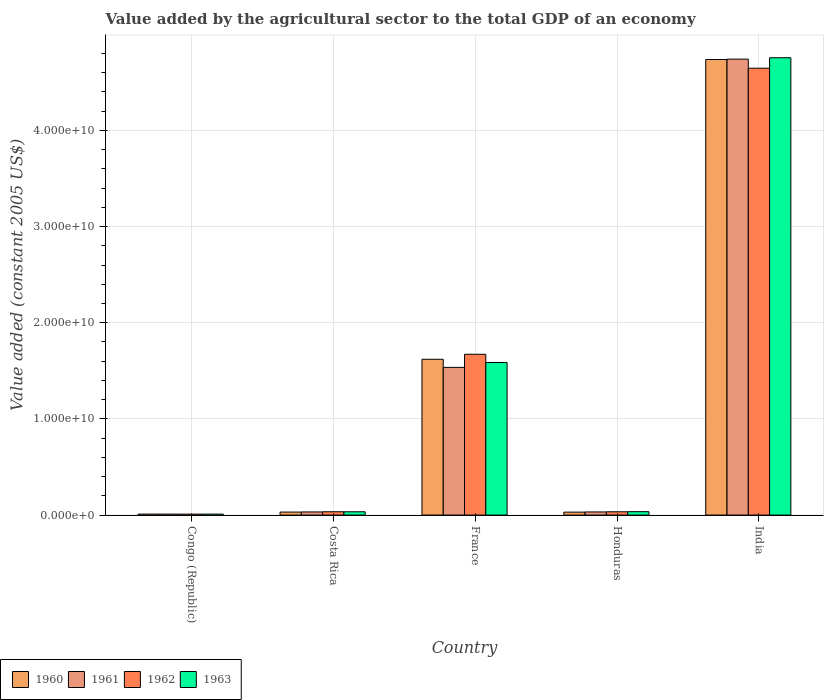How many different coloured bars are there?
Your answer should be very brief. 4. Are the number of bars per tick equal to the number of legend labels?
Keep it short and to the point. Yes. Are the number of bars on each tick of the X-axis equal?
Provide a short and direct response. Yes. How many bars are there on the 2nd tick from the left?
Offer a very short reply. 4. How many bars are there on the 2nd tick from the right?
Make the answer very short. 4. What is the label of the 4th group of bars from the left?
Your answer should be very brief. Honduras. What is the value added by the agricultural sector in 1960 in France?
Provide a succinct answer. 1.62e+1. Across all countries, what is the maximum value added by the agricultural sector in 1961?
Make the answer very short. 4.74e+1. Across all countries, what is the minimum value added by the agricultural sector in 1961?
Your answer should be compact. 9.74e+07. In which country was the value added by the agricultural sector in 1960 maximum?
Provide a short and direct response. India. In which country was the value added by the agricultural sector in 1963 minimum?
Provide a short and direct response. Congo (Republic). What is the total value added by the agricultural sector in 1961 in the graph?
Provide a short and direct response. 6.35e+1. What is the difference between the value added by the agricultural sector in 1961 in Costa Rica and that in India?
Give a very brief answer. -4.71e+1. What is the difference between the value added by the agricultural sector in 1963 in Costa Rica and the value added by the agricultural sector in 1962 in India?
Provide a short and direct response. -4.61e+1. What is the average value added by the agricultural sector in 1962 per country?
Your answer should be very brief. 1.28e+1. What is the difference between the value added by the agricultural sector of/in 1960 and value added by the agricultural sector of/in 1962 in India?
Ensure brevity in your answer.  9.03e+08. What is the ratio of the value added by the agricultural sector in 1961 in Congo (Republic) to that in India?
Make the answer very short. 0. Is the value added by the agricultural sector in 1960 in Congo (Republic) less than that in Honduras?
Ensure brevity in your answer.  Yes. Is the difference between the value added by the agricultural sector in 1960 in Costa Rica and France greater than the difference between the value added by the agricultural sector in 1962 in Costa Rica and France?
Provide a succinct answer. Yes. What is the difference between the highest and the second highest value added by the agricultural sector in 1960?
Ensure brevity in your answer.  3.12e+1. What is the difference between the highest and the lowest value added by the agricultural sector in 1962?
Offer a very short reply. 4.64e+1. Is the sum of the value added by the agricultural sector in 1960 in Costa Rica and India greater than the maximum value added by the agricultural sector in 1962 across all countries?
Your answer should be very brief. Yes. What does the 1st bar from the left in Costa Rica represents?
Offer a terse response. 1960. What does the 4th bar from the right in Congo (Republic) represents?
Make the answer very short. 1960. Is it the case that in every country, the sum of the value added by the agricultural sector in 1963 and value added by the agricultural sector in 1960 is greater than the value added by the agricultural sector in 1962?
Your answer should be very brief. Yes. How many bars are there?
Your answer should be compact. 20. Are all the bars in the graph horizontal?
Provide a succinct answer. No. How many countries are there in the graph?
Your answer should be very brief. 5. Does the graph contain any zero values?
Ensure brevity in your answer.  No. Does the graph contain grids?
Ensure brevity in your answer.  Yes. Where does the legend appear in the graph?
Offer a terse response. Bottom left. How many legend labels are there?
Keep it short and to the point. 4. What is the title of the graph?
Your answer should be very brief. Value added by the agricultural sector to the total GDP of an economy. Does "1967" appear as one of the legend labels in the graph?
Your answer should be compact. No. What is the label or title of the Y-axis?
Offer a very short reply. Value added (constant 2005 US$). What is the Value added (constant 2005 US$) in 1960 in Congo (Republic)?
Make the answer very short. 1.01e+08. What is the Value added (constant 2005 US$) of 1961 in Congo (Republic)?
Ensure brevity in your answer.  9.74e+07. What is the Value added (constant 2005 US$) in 1962 in Congo (Republic)?
Make the answer very short. 9.79e+07. What is the Value added (constant 2005 US$) in 1963 in Congo (Republic)?
Give a very brief answer. 9.86e+07. What is the Value added (constant 2005 US$) of 1960 in Costa Rica?
Give a very brief answer. 3.13e+08. What is the Value added (constant 2005 US$) in 1961 in Costa Rica?
Your response must be concise. 3.24e+08. What is the Value added (constant 2005 US$) in 1962 in Costa Rica?
Your answer should be very brief. 3.44e+08. What is the Value added (constant 2005 US$) in 1963 in Costa Rica?
Your answer should be very brief. 3.43e+08. What is the Value added (constant 2005 US$) of 1960 in France?
Your response must be concise. 1.62e+1. What is the Value added (constant 2005 US$) in 1961 in France?
Offer a terse response. 1.54e+1. What is the Value added (constant 2005 US$) of 1962 in France?
Provide a short and direct response. 1.67e+1. What is the Value added (constant 2005 US$) of 1963 in France?
Your response must be concise. 1.59e+1. What is the Value added (constant 2005 US$) in 1960 in Honduras?
Offer a very short reply. 3.05e+08. What is the Value added (constant 2005 US$) of 1961 in Honduras?
Keep it short and to the point. 3.25e+08. What is the Value added (constant 2005 US$) in 1962 in Honduras?
Your answer should be compact. 3.41e+08. What is the Value added (constant 2005 US$) of 1963 in Honduras?
Your answer should be very brief. 3.53e+08. What is the Value added (constant 2005 US$) of 1960 in India?
Offer a very short reply. 4.74e+1. What is the Value added (constant 2005 US$) of 1961 in India?
Keep it short and to the point. 4.74e+1. What is the Value added (constant 2005 US$) of 1962 in India?
Offer a terse response. 4.65e+1. What is the Value added (constant 2005 US$) of 1963 in India?
Provide a short and direct response. 4.76e+1. Across all countries, what is the maximum Value added (constant 2005 US$) of 1960?
Your answer should be compact. 4.74e+1. Across all countries, what is the maximum Value added (constant 2005 US$) in 1961?
Ensure brevity in your answer.  4.74e+1. Across all countries, what is the maximum Value added (constant 2005 US$) in 1962?
Ensure brevity in your answer.  4.65e+1. Across all countries, what is the maximum Value added (constant 2005 US$) of 1963?
Offer a terse response. 4.76e+1. Across all countries, what is the minimum Value added (constant 2005 US$) of 1960?
Offer a very short reply. 1.01e+08. Across all countries, what is the minimum Value added (constant 2005 US$) of 1961?
Your answer should be compact. 9.74e+07. Across all countries, what is the minimum Value added (constant 2005 US$) in 1962?
Offer a terse response. 9.79e+07. Across all countries, what is the minimum Value added (constant 2005 US$) in 1963?
Provide a short and direct response. 9.86e+07. What is the total Value added (constant 2005 US$) in 1960 in the graph?
Provide a short and direct response. 6.43e+1. What is the total Value added (constant 2005 US$) of 1961 in the graph?
Offer a terse response. 6.35e+1. What is the total Value added (constant 2005 US$) in 1962 in the graph?
Give a very brief answer. 6.40e+1. What is the total Value added (constant 2005 US$) of 1963 in the graph?
Give a very brief answer. 6.42e+1. What is the difference between the Value added (constant 2005 US$) in 1960 in Congo (Republic) and that in Costa Rica?
Keep it short and to the point. -2.12e+08. What is the difference between the Value added (constant 2005 US$) in 1961 in Congo (Republic) and that in Costa Rica?
Your answer should be compact. -2.27e+08. What is the difference between the Value added (constant 2005 US$) in 1962 in Congo (Republic) and that in Costa Rica?
Provide a short and direct response. -2.46e+08. What is the difference between the Value added (constant 2005 US$) of 1963 in Congo (Republic) and that in Costa Rica?
Provide a short and direct response. -2.45e+08. What is the difference between the Value added (constant 2005 US$) in 1960 in Congo (Republic) and that in France?
Ensure brevity in your answer.  -1.61e+1. What is the difference between the Value added (constant 2005 US$) in 1961 in Congo (Republic) and that in France?
Offer a terse response. -1.53e+1. What is the difference between the Value added (constant 2005 US$) in 1962 in Congo (Republic) and that in France?
Provide a short and direct response. -1.66e+1. What is the difference between the Value added (constant 2005 US$) of 1963 in Congo (Republic) and that in France?
Offer a very short reply. -1.58e+1. What is the difference between the Value added (constant 2005 US$) of 1960 in Congo (Republic) and that in Honduras?
Your answer should be compact. -2.04e+08. What is the difference between the Value added (constant 2005 US$) in 1961 in Congo (Republic) and that in Honduras?
Provide a short and direct response. -2.28e+08. What is the difference between the Value added (constant 2005 US$) in 1962 in Congo (Republic) and that in Honduras?
Your response must be concise. -2.43e+08. What is the difference between the Value added (constant 2005 US$) in 1963 in Congo (Republic) and that in Honduras?
Provide a short and direct response. -2.55e+08. What is the difference between the Value added (constant 2005 US$) in 1960 in Congo (Republic) and that in India?
Make the answer very short. -4.73e+1. What is the difference between the Value added (constant 2005 US$) in 1961 in Congo (Republic) and that in India?
Your response must be concise. -4.73e+1. What is the difference between the Value added (constant 2005 US$) of 1962 in Congo (Republic) and that in India?
Your answer should be very brief. -4.64e+1. What is the difference between the Value added (constant 2005 US$) in 1963 in Congo (Republic) and that in India?
Offer a very short reply. -4.75e+1. What is the difference between the Value added (constant 2005 US$) of 1960 in Costa Rica and that in France?
Make the answer very short. -1.59e+1. What is the difference between the Value added (constant 2005 US$) of 1961 in Costa Rica and that in France?
Make the answer very short. -1.50e+1. What is the difference between the Value added (constant 2005 US$) of 1962 in Costa Rica and that in France?
Your response must be concise. -1.64e+1. What is the difference between the Value added (constant 2005 US$) in 1963 in Costa Rica and that in France?
Your answer should be compact. -1.55e+1. What is the difference between the Value added (constant 2005 US$) of 1960 in Costa Rica and that in Honduras?
Keep it short and to the point. 7.61e+06. What is the difference between the Value added (constant 2005 US$) in 1961 in Costa Rica and that in Honduras?
Offer a very short reply. -8.14e+05. What is the difference between the Value added (constant 2005 US$) of 1962 in Costa Rica and that in Honduras?
Your answer should be compact. 3.61e+06. What is the difference between the Value added (constant 2005 US$) in 1963 in Costa Rica and that in Honduras?
Ensure brevity in your answer.  -9.78e+06. What is the difference between the Value added (constant 2005 US$) of 1960 in Costa Rica and that in India?
Provide a short and direct response. -4.71e+1. What is the difference between the Value added (constant 2005 US$) of 1961 in Costa Rica and that in India?
Your answer should be compact. -4.71e+1. What is the difference between the Value added (constant 2005 US$) in 1962 in Costa Rica and that in India?
Keep it short and to the point. -4.61e+1. What is the difference between the Value added (constant 2005 US$) of 1963 in Costa Rica and that in India?
Your answer should be compact. -4.72e+1. What is the difference between the Value added (constant 2005 US$) of 1960 in France and that in Honduras?
Offer a very short reply. 1.59e+1. What is the difference between the Value added (constant 2005 US$) of 1961 in France and that in Honduras?
Provide a succinct answer. 1.50e+1. What is the difference between the Value added (constant 2005 US$) in 1962 in France and that in Honduras?
Your response must be concise. 1.64e+1. What is the difference between the Value added (constant 2005 US$) of 1963 in France and that in Honduras?
Make the answer very short. 1.55e+1. What is the difference between the Value added (constant 2005 US$) of 1960 in France and that in India?
Your answer should be very brief. -3.12e+1. What is the difference between the Value added (constant 2005 US$) in 1961 in France and that in India?
Your answer should be compact. -3.21e+1. What is the difference between the Value added (constant 2005 US$) of 1962 in France and that in India?
Your answer should be compact. -2.97e+1. What is the difference between the Value added (constant 2005 US$) of 1963 in France and that in India?
Make the answer very short. -3.17e+1. What is the difference between the Value added (constant 2005 US$) of 1960 in Honduras and that in India?
Make the answer very short. -4.71e+1. What is the difference between the Value added (constant 2005 US$) in 1961 in Honduras and that in India?
Provide a succinct answer. -4.71e+1. What is the difference between the Value added (constant 2005 US$) of 1962 in Honduras and that in India?
Ensure brevity in your answer.  -4.61e+1. What is the difference between the Value added (constant 2005 US$) in 1963 in Honduras and that in India?
Your answer should be compact. -4.72e+1. What is the difference between the Value added (constant 2005 US$) of 1960 in Congo (Republic) and the Value added (constant 2005 US$) of 1961 in Costa Rica?
Offer a very short reply. -2.24e+08. What is the difference between the Value added (constant 2005 US$) of 1960 in Congo (Republic) and the Value added (constant 2005 US$) of 1962 in Costa Rica?
Ensure brevity in your answer.  -2.43e+08. What is the difference between the Value added (constant 2005 US$) of 1960 in Congo (Republic) and the Value added (constant 2005 US$) of 1963 in Costa Rica?
Keep it short and to the point. -2.42e+08. What is the difference between the Value added (constant 2005 US$) of 1961 in Congo (Republic) and the Value added (constant 2005 US$) of 1962 in Costa Rica?
Provide a succinct answer. -2.47e+08. What is the difference between the Value added (constant 2005 US$) of 1961 in Congo (Republic) and the Value added (constant 2005 US$) of 1963 in Costa Rica?
Ensure brevity in your answer.  -2.46e+08. What is the difference between the Value added (constant 2005 US$) of 1962 in Congo (Republic) and the Value added (constant 2005 US$) of 1963 in Costa Rica?
Your response must be concise. -2.45e+08. What is the difference between the Value added (constant 2005 US$) in 1960 in Congo (Republic) and the Value added (constant 2005 US$) in 1961 in France?
Provide a short and direct response. -1.53e+1. What is the difference between the Value added (constant 2005 US$) in 1960 in Congo (Republic) and the Value added (constant 2005 US$) in 1962 in France?
Offer a very short reply. -1.66e+1. What is the difference between the Value added (constant 2005 US$) of 1960 in Congo (Republic) and the Value added (constant 2005 US$) of 1963 in France?
Ensure brevity in your answer.  -1.58e+1. What is the difference between the Value added (constant 2005 US$) in 1961 in Congo (Republic) and the Value added (constant 2005 US$) in 1962 in France?
Make the answer very short. -1.66e+1. What is the difference between the Value added (constant 2005 US$) in 1961 in Congo (Republic) and the Value added (constant 2005 US$) in 1963 in France?
Your answer should be compact. -1.58e+1. What is the difference between the Value added (constant 2005 US$) of 1962 in Congo (Republic) and the Value added (constant 2005 US$) of 1963 in France?
Provide a succinct answer. -1.58e+1. What is the difference between the Value added (constant 2005 US$) in 1960 in Congo (Republic) and the Value added (constant 2005 US$) in 1961 in Honduras?
Your response must be concise. -2.24e+08. What is the difference between the Value added (constant 2005 US$) in 1960 in Congo (Republic) and the Value added (constant 2005 US$) in 1962 in Honduras?
Offer a very short reply. -2.40e+08. What is the difference between the Value added (constant 2005 US$) of 1960 in Congo (Republic) and the Value added (constant 2005 US$) of 1963 in Honduras?
Provide a short and direct response. -2.52e+08. What is the difference between the Value added (constant 2005 US$) of 1961 in Congo (Republic) and the Value added (constant 2005 US$) of 1962 in Honduras?
Offer a very short reply. -2.43e+08. What is the difference between the Value added (constant 2005 US$) in 1961 in Congo (Republic) and the Value added (constant 2005 US$) in 1963 in Honduras?
Your answer should be compact. -2.56e+08. What is the difference between the Value added (constant 2005 US$) of 1962 in Congo (Republic) and the Value added (constant 2005 US$) of 1963 in Honduras?
Your answer should be very brief. -2.55e+08. What is the difference between the Value added (constant 2005 US$) of 1960 in Congo (Republic) and the Value added (constant 2005 US$) of 1961 in India?
Provide a short and direct response. -4.73e+1. What is the difference between the Value added (constant 2005 US$) of 1960 in Congo (Republic) and the Value added (constant 2005 US$) of 1962 in India?
Keep it short and to the point. -4.64e+1. What is the difference between the Value added (constant 2005 US$) in 1960 in Congo (Republic) and the Value added (constant 2005 US$) in 1963 in India?
Offer a terse response. -4.75e+1. What is the difference between the Value added (constant 2005 US$) in 1961 in Congo (Republic) and the Value added (constant 2005 US$) in 1962 in India?
Offer a terse response. -4.64e+1. What is the difference between the Value added (constant 2005 US$) of 1961 in Congo (Republic) and the Value added (constant 2005 US$) of 1963 in India?
Offer a very short reply. -4.75e+1. What is the difference between the Value added (constant 2005 US$) of 1962 in Congo (Republic) and the Value added (constant 2005 US$) of 1963 in India?
Keep it short and to the point. -4.75e+1. What is the difference between the Value added (constant 2005 US$) in 1960 in Costa Rica and the Value added (constant 2005 US$) in 1961 in France?
Provide a succinct answer. -1.50e+1. What is the difference between the Value added (constant 2005 US$) of 1960 in Costa Rica and the Value added (constant 2005 US$) of 1962 in France?
Make the answer very short. -1.64e+1. What is the difference between the Value added (constant 2005 US$) in 1960 in Costa Rica and the Value added (constant 2005 US$) in 1963 in France?
Offer a very short reply. -1.56e+1. What is the difference between the Value added (constant 2005 US$) in 1961 in Costa Rica and the Value added (constant 2005 US$) in 1962 in France?
Your answer should be very brief. -1.64e+1. What is the difference between the Value added (constant 2005 US$) in 1961 in Costa Rica and the Value added (constant 2005 US$) in 1963 in France?
Make the answer very short. -1.55e+1. What is the difference between the Value added (constant 2005 US$) in 1962 in Costa Rica and the Value added (constant 2005 US$) in 1963 in France?
Provide a short and direct response. -1.55e+1. What is the difference between the Value added (constant 2005 US$) of 1960 in Costa Rica and the Value added (constant 2005 US$) of 1961 in Honduras?
Offer a terse response. -1.23e+07. What is the difference between the Value added (constant 2005 US$) in 1960 in Costa Rica and the Value added (constant 2005 US$) in 1962 in Honduras?
Provide a short and direct response. -2.78e+07. What is the difference between the Value added (constant 2005 US$) of 1960 in Costa Rica and the Value added (constant 2005 US$) of 1963 in Honduras?
Offer a very short reply. -4.02e+07. What is the difference between the Value added (constant 2005 US$) of 1961 in Costa Rica and the Value added (constant 2005 US$) of 1962 in Honduras?
Offer a terse response. -1.63e+07. What is the difference between the Value added (constant 2005 US$) in 1961 in Costa Rica and the Value added (constant 2005 US$) in 1963 in Honduras?
Your answer should be very brief. -2.87e+07. What is the difference between the Value added (constant 2005 US$) of 1962 in Costa Rica and the Value added (constant 2005 US$) of 1963 in Honduras?
Give a very brief answer. -8.78e+06. What is the difference between the Value added (constant 2005 US$) of 1960 in Costa Rica and the Value added (constant 2005 US$) of 1961 in India?
Make the answer very short. -4.71e+1. What is the difference between the Value added (constant 2005 US$) of 1960 in Costa Rica and the Value added (constant 2005 US$) of 1962 in India?
Your answer should be very brief. -4.62e+1. What is the difference between the Value added (constant 2005 US$) of 1960 in Costa Rica and the Value added (constant 2005 US$) of 1963 in India?
Provide a short and direct response. -4.72e+1. What is the difference between the Value added (constant 2005 US$) of 1961 in Costa Rica and the Value added (constant 2005 US$) of 1962 in India?
Give a very brief answer. -4.61e+1. What is the difference between the Value added (constant 2005 US$) in 1961 in Costa Rica and the Value added (constant 2005 US$) in 1963 in India?
Provide a short and direct response. -4.72e+1. What is the difference between the Value added (constant 2005 US$) in 1962 in Costa Rica and the Value added (constant 2005 US$) in 1963 in India?
Offer a very short reply. -4.72e+1. What is the difference between the Value added (constant 2005 US$) in 1960 in France and the Value added (constant 2005 US$) in 1961 in Honduras?
Offer a terse response. 1.59e+1. What is the difference between the Value added (constant 2005 US$) of 1960 in France and the Value added (constant 2005 US$) of 1962 in Honduras?
Offer a very short reply. 1.59e+1. What is the difference between the Value added (constant 2005 US$) of 1960 in France and the Value added (constant 2005 US$) of 1963 in Honduras?
Your answer should be compact. 1.58e+1. What is the difference between the Value added (constant 2005 US$) in 1961 in France and the Value added (constant 2005 US$) in 1962 in Honduras?
Provide a short and direct response. 1.50e+1. What is the difference between the Value added (constant 2005 US$) of 1961 in France and the Value added (constant 2005 US$) of 1963 in Honduras?
Keep it short and to the point. 1.50e+1. What is the difference between the Value added (constant 2005 US$) in 1962 in France and the Value added (constant 2005 US$) in 1963 in Honduras?
Offer a very short reply. 1.64e+1. What is the difference between the Value added (constant 2005 US$) of 1960 in France and the Value added (constant 2005 US$) of 1961 in India?
Make the answer very short. -3.12e+1. What is the difference between the Value added (constant 2005 US$) in 1960 in France and the Value added (constant 2005 US$) in 1962 in India?
Keep it short and to the point. -3.03e+1. What is the difference between the Value added (constant 2005 US$) of 1960 in France and the Value added (constant 2005 US$) of 1963 in India?
Your answer should be very brief. -3.14e+1. What is the difference between the Value added (constant 2005 US$) in 1961 in France and the Value added (constant 2005 US$) in 1962 in India?
Your answer should be compact. -3.11e+1. What is the difference between the Value added (constant 2005 US$) in 1961 in France and the Value added (constant 2005 US$) in 1963 in India?
Your answer should be compact. -3.22e+1. What is the difference between the Value added (constant 2005 US$) in 1962 in France and the Value added (constant 2005 US$) in 1963 in India?
Your answer should be very brief. -3.08e+1. What is the difference between the Value added (constant 2005 US$) in 1960 in Honduras and the Value added (constant 2005 US$) in 1961 in India?
Give a very brief answer. -4.71e+1. What is the difference between the Value added (constant 2005 US$) of 1960 in Honduras and the Value added (constant 2005 US$) of 1962 in India?
Offer a very short reply. -4.62e+1. What is the difference between the Value added (constant 2005 US$) in 1960 in Honduras and the Value added (constant 2005 US$) in 1963 in India?
Make the answer very short. -4.72e+1. What is the difference between the Value added (constant 2005 US$) in 1961 in Honduras and the Value added (constant 2005 US$) in 1962 in India?
Offer a terse response. -4.61e+1. What is the difference between the Value added (constant 2005 US$) of 1961 in Honduras and the Value added (constant 2005 US$) of 1963 in India?
Give a very brief answer. -4.72e+1. What is the difference between the Value added (constant 2005 US$) of 1962 in Honduras and the Value added (constant 2005 US$) of 1963 in India?
Ensure brevity in your answer.  -4.72e+1. What is the average Value added (constant 2005 US$) of 1960 per country?
Offer a terse response. 1.29e+1. What is the average Value added (constant 2005 US$) in 1961 per country?
Provide a short and direct response. 1.27e+1. What is the average Value added (constant 2005 US$) of 1962 per country?
Offer a very short reply. 1.28e+1. What is the average Value added (constant 2005 US$) in 1963 per country?
Offer a terse response. 1.28e+1. What is the difference between the Value added (constant 2005 US$) in 1960 and Value added (constant 2005 US$) in 1961 in Congo (Republic)?
Your answer should be compact. 3.61e+06. What is the difference between the Value added (constant 2005 US$) in 1960 and Value added (constant 2005 US$) in 1962 in Congo (Republic)?
Provide a succinct answer. 3.02e+06. What is the difference between the Value added (constant 2005 US$) of 1960 and Value added (constant 2005 US$) of 1963 in Congo (Republic)?
Your answer should be compact. 2.34e+06. What is the difference between the Value added (constant 2005 US$) of 1961 and Value added (constant 2005 US$) of 1962 in Congo (Republic)?
Your answer should be very brief. -5.86e+05. What is the difference between the Value added (constant 2005 US$) of 1961 and Value added (constant 2005 US$) of 1963 in Congo (Republic)?
Your answer should be very brief. -1.27e+06. What is the difference between the Value added (constant 2005 US$) in 1962 and Value added (constant 2005 US$) in 1963 in Congo (Republic)?
Provide a succinct answer. -6.85e+05. What is the difference between the Value added (constant 2005 US$) of 1960 and Value added (constant 2005 US$) of 1961 in Costa Rica?
Give a very brief answer. -1.15e+07. What is the difference between the Value added (constant 2005 US$) of 1960 and Value added (constant 2005 US$) of 1962 in Costa Rica?
Your answer should be compact. -3.14e+07. What is the difference between the Value added (constant 2005 US$) in 1960 and Value added (constant 2005 US$) in 1963 in Costa Rica?
Make the answer very short. -3.04e+07. What is the difference between the Value added (constant 2005 US$) of 1961 and Value added (constant 2005 US$) of 1962 in Costa Rica?
Ensure brevity in your answer.  -1.99e+07. What is the difference between the Value added (constant 2005 US$) in 1961 and Value added (constant 2005 US$) in 1963 in Costa Rica?
Your response must be concise. -1.89e+07. What is the difference between the Value added (constant 2005 US$) in 1962 and Value added (constant 2005 US$) in 1963 in Costa Rica?
Provide a short and direct response. 1.00e+06. What is the difference between the Value added (constant 2005 US$) of 1960 and Value added (constant 2005 US$) of 1961 in France?
Provide a succinct answer. 8.42e+08. What is the difference between the Value added (constant 2005 US$) in 1960 and Value added (constant 2005 US$) in 1962 in France?
Your response must be concise. -5.20e+08. What is the difference between the Value added (constant 2005 US$) in 1960 and Value added (constant 2005 US$) in 1963 in France?
Provide a succinct answer. 3.35e+08. What is the difference between the Value added (constant 2005 US$) in 1961 and Value added (constant 2005 US$) in 1962 in France?
Make the answer very short. -1.36e+09. What is the difference between the Value added (constant 2005 US$) of 1961 and Value added (constant 2005 US$) of 1963 in France?
Your response must be concise. -5.07e+08. What is the difference between the Value added (constant 2005 US$) of 1962 and Value added (constant 2005 US$) of 1963 in France?
Provide a short and direct response. 8.56e+08. What is the difference between the Value added (constant 2005 US$) in 1960 and Value added (constant 2005 US$) in 1961 in Honduras?
Ensure brevity in your answer.  -1.99e+07. What is the difference between the Value added (constant 2005 US$) of 1960 and Value added (constant 2005 US$) of 1962 in Honduras?
Provide a succinct answer. -3.54e+07. What is the difference between the Value added (constant 2005 US$) in 1960 and Value added (constant 2005 US$) in 1963 in Honduras?
Give a very brief answer. -4.78e+07. What is the difference between the Value added (constant 2005 US$) of 1961 and Value added (constant 2005 US$) of 1962 in Honduras?
Your answer should be compact. -1.55e+07. What is the difference between the Value added (constant 2005 US$) of 1961 and Value added (constant 2005 US$) of 1963 in Honduras?
Your answer should be very brief. -2.79e+07. What is the difference between the Value added (constant 2005 US$) in 1962 and Value added (constant 2005 US$) in 1963 in Honduras?
Ensure brevity in your answer.  -1.24e+07. What is the difference between the Value added (constant 2005 US$) of 1960 and Value added (constant 2005 US$) of 1961 in India?
Give a very brief answer. -3.99e+07. What is the difference between the Value added (constant 2005 US$) of 1960 and Value added (constant 2005 US$) of 1962 in India?
Offer a terse response. 9.03e+08. What is the difference between the Value added (constant 2005 US$) of 1960 and Value added (constant 2005 US$) of 1963 in India?
Offer a terse response. -1.84e+08. What is the difference between the Value added (constant 2005 US$) of 1961 and Value added (constant 2005 US$) of 1962 in India?
Keep it short and to the point. 9.43e+08. What is the difference between the Value added (constant 2005 US$) in 1961 and Value added (constant 2005 US$) in 1963 in India?
Ensure brevity in your answer.  -1.44e+08. What is the difference between the Value added (constant 2005 US$) in 1962 and Value added (constant 2005 US$) in 1963 in India?
Provide a short and direct response. -1.09e+09. What is the ratio of the Value added (constant 2005 US$) in 1960 in Congo (Republic) to that in Costa Rica?
Provide a succinct answer. 0.32. What is the ratio of the Value added (constant 2005 US$) of 1961 in Congo (Republic) to that in Costa Rica?
Offer a very short reply. 0.3. What is the ratio of the Value added (constant 2005 US$) in 1962 in Congo (Republic) to that in Costa Rica?
Your answer should be compact. 0.28. What is the ratio of the Value added (constant 2005 US$) of 1963 in Congo (Republic) to that in Costa Rica?
Ensure brevity in your answer.  0.29. What is the ratio of the Value added (constant 2005 US$) of 1960 in Congo (Republic) to that in France?
Provide a succinct answer. 0.01. What is the ratio of the Value added (constant 2005 US$) in 1961 in Congo (Republic) to that in France?
Offer a very short reply. 0.01. What is the ratio of the Value added (constant 2005 US$) of 1962 in Congo (Republic) to that in France?
Ensure brevity in your answer.  0.01. What is the ratio of the Value added (constant 2005 US$) of 1963 in Congo (Republic) to that in France?
Provide a short and direct response. 0.01. What is the ratio of the Value added (constant 2005 US$) in 1960 in Congo (Republic) to that in Honduras?
Ensure brevity in your answer.  0.33. What is the ratio of the Value added (constant 2005 US$) in 1961 in Congo (Republic) to that in Honduras?
Ensure brevity in your answer.  0.3. What is the ratio of the Value added (constant 2005 US$) in 1962 in Congo (Republic) to that in Honduras?
Your answer should be very brief. 0.29. What is the ratio of the Value added (constant 2005 US$) in 1963 in Congo (Republic) to that in Honduras?
Make the answer very short. 0.28. What is the ratio of the Value added (constant 2005 US$) of 1960 in Congo (Republic) to that in India?
Your answer should be compact. 0. What is the ratio of the Value added (constant 2005 US$) in 1961 in Congo (Republic) to that in India?
Your answer should be compact. 0. What is the ratio of the Value added (constant 2005 US$) of 1962 in Congo (Republic) to that in India?
Provide a succinct answer. 0. What is the ratio of the Value added (constant 2005 US$) in 1963 in Congo (Republic) to that in India?
Provide a succinct answer. 0. What is the ratio of the Value added (constant 2005 US$) of 1960 in Costa Rica to that in France?
Make the answer very short. 0.02. What is the ratio of the Value added (constant 2005 US$) of 1961 in Costa Rica to that in France?
Your response must be concise. 0.02. What is the ratio of the Value added (constant 2005 US$) in 1962 in Costa Rica to that in France?
Provide a short and direct response. 0.02. What is the ratio of the Value added (constant 2005 US$) in 1963 in Costa Rica to that in France?
Your answer should be very brief. 0.02. What is the ratio of the Value added (constant 2005 US$) of 1960 in Costa Rica to that in Honduras?
Your answer should be compact. 1.02. What is the ratio of the Value added (constant 2005 US$) of 1962 in Costa Rica to that in Honduras?
Give a very brief answer. 1.01. What is the ratio of the Value added (constant 2005 US$) of 1963 in Costa Rica to that in Honduras?
Provide a succinct answer. 0.97. What is the ratio of the Value added (constant 2005 US$) of 1960 in Costa Rica to that in India?
Make the answer very short. 0.01. What is the ratio of the Value added (constant 2005 US$) in 1961 in Costa Rica to that in India?
Give a very brief answer. 0.01. What is the ratio of the Value added (constant 2005 US$) of 1962 in Costa Rica to that in India?
Keep it short and to the point. 0.01. What is the ratio of the Value added (constant 2005 US$) in 1963 in Costa Rica to that in India?
Offer a very short reply. 0.01. What is the ratio of the Value added (constant 2005 US$) in 1960 in France to that in Honduras?
Ensure brevity in your answer.  53.05. What is the ratio of the Value added (constant 2005 US$) in 1961 in France to that in Honduras?
Give a very brief answer. 47.21. What is the ratio of the Value added (constant 2005 US$) in 1962 in France to that in Honduras?
Provide a short and direct response. 49.07. What is the ratio of the Value added (constant 2005 US$) of 1963 in France to that in Honduras?
Offer a terse response. 44.92. What is the ratio of the Value added (constant 2005 US$) in 1960 in France to that in India?
Provide a short and direct response. 0.34. What is the ratio of the Value added (constant 2005 US$) of 1961 in France to that in India?
Provide a succinct answer. 0.32. What is the ratio of the Value added (constant 2005 US$) of 1962 in France to that in India?
Your answer should be very brief. 0.36. What is the ratio of the Value added (constant 2005 US$) in 1963 in France to that in India?
Offer a terse response. 0.33. What is the ratio of the Value added (constant 2005 US$) in 1960 in Honduras to that in India?
Provide a succinct answer. 0.01. What is the ratio of the Value added (constant 2005 US$) in 1961 in Honduras to that in India?
Provide a succinct answer. 0.01. What is the ratio of the Value added (constant 2005 US$) of 1962 in Honduras to that in India?
Give a very brief answer. 0.01. What is the ratio of the Value added (constant 2005 US$) in 1963 in Honduras to that in India?
Your answer should be very brief. 0.01. What is the difference between the highest and the second highest Value added (constant 2005 US$) of 1960?
Ensure brevity in your answer.  3.12e+1. What is the difference between the highest and the second highest Value added (constant 2005 US$) in 1961?
Offer a terse response. 3.21e+1. What is the difference between the highest and the second highest Value added (constant 2005 US$) of 1962?
Keep it short and to the point. 2.97e+1. What is the difference between the highest and the second highest Value added (constant 2005 US$) in 1963?
Give a very brief answer. 3.17e+1. What is the difference between the highest and the lowest Value added (constant 2005 US$) in 1960?
Provide a short and direct response. 4.73e+1. What is the difference between the highest and the lowest Value added (constant 2005 US$) in 1961?
Ensure brevity in your answer.  4.73e+1. What is the difference between the highest and the lowest Value added (constant 2005 US$) of 1962?
Ensure brevity in your answer.  4.64e+1. What is the difference between the highest and the lowest Value added (constant 2005 US$) in 1963?
Your response must be concise. 4.75e+1. 